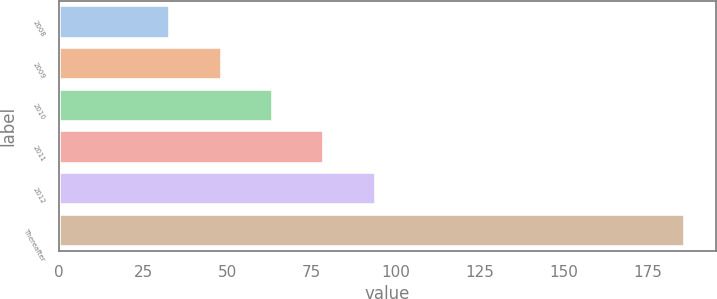Convert chart. <chart><loc_0><loc_0><loc_500><loc_500><bar_chart><fcel>2008<fcel>2009<fcel>2010<fcel>2011<fcel>2012<fcel>Thereafter<nl><fcel>33<fcel>48.3<fcel>63.6<fcel>78.9<fcel>94.2<fcel>186<nl></chart> 